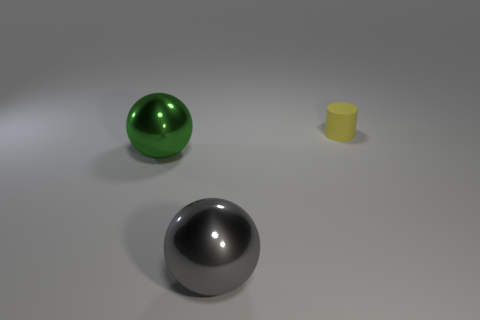Are there any other things that have the same material as the cylinder?
Offer a terse response. No. There is a object that is in front of the big ball on the left side of the metal object right of the large green object; how big is it?
Offer a terse response. Large. There is a sphere right of the big green metal object; is there a big thing that is behind it?
Your answer should be very brief. Yes. How many big gray balls are right of the yellow thing that is behind the large sphere that is in front of the green metallic thing?
Provide a succinct answer. 0. There is a object that is both to the left of the small yellow cylinder and behind the gray shiny thing; what color is it?
Your response must be concise. Green. What number of big metallic things have the same color as the tiny cylinder?
Offer a terse response. 0. How many spheres are gray things or small red things?
Ensure brevity in your answer.  1. There is a ball that is the same size as the green shiny thing; what is its color?
Provide a succinct answer. Gray. Are there any objects that are behind the big metal thing that is right of the large shiny thing left of the gray object?
Give a very brief answer. Yes. How big is the yellow cylinder?
Provide a succinct answer. Small. 